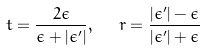Convert formula to latex. <formula><loc_0><loc_0><loc_500><loc_500>t = \frac { 2 \epsilon } { \epsilon + | \epsilon ^ { \prime } | } , \ \ r = \frac { | \epsilon ^ { \prime } | - \epsilon } { | \epsilon ^ { \prime } | + \epsilon }</formula> 